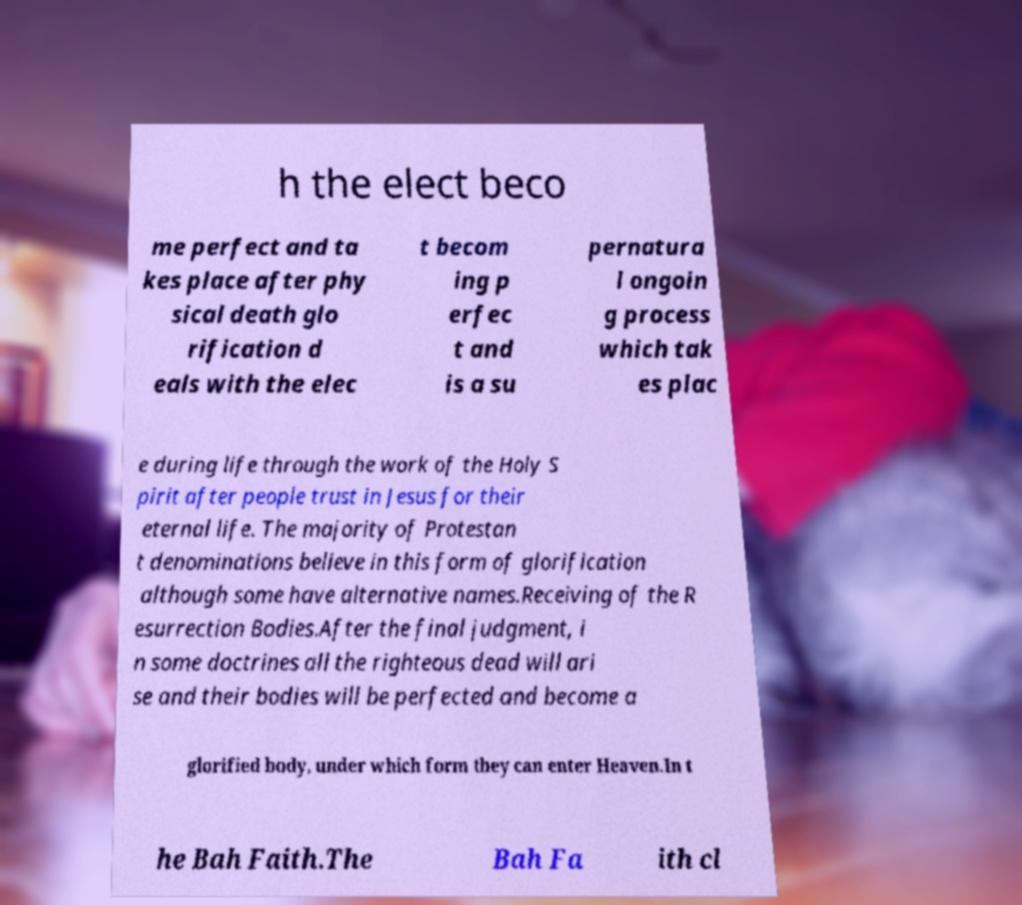Please read and relay the text visible in this image. What does it say? h the elect beco me perfect and ta kes place after phy sical death glo rification d eals with the elec t becom ing p erfec t and is a su pernatura l ongoin g process which tak es plac e during life through the work of the Holy S pirit after people trust in Jesus for their eternal life. The majority of Protestan t denominations believe in this form of glorification although some have alternative names.Receiving of the R esurrection Bodies.After the final judgment, i n some doctrines all the righteous dead will ari se and their bodies will be perfected and become a glorified body, under which form they can enter Heaven.In t he Bah Faith.The Bah Fa ith cl 